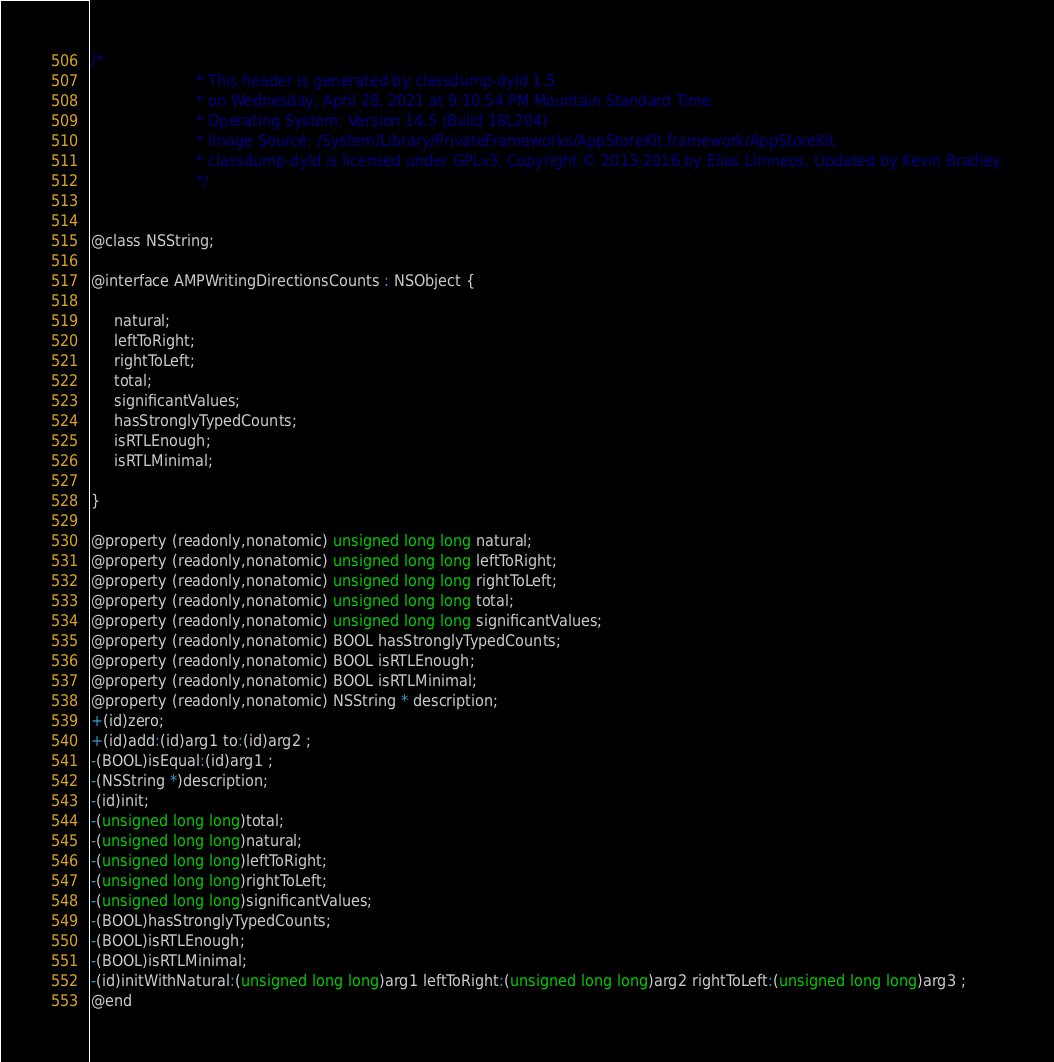<code> <loc_0><loc_0><loc_500><loc_500><_C_>/*
                       * This header is generated by classdump-dyld 1.5
                       * on Wednesday, April 28, 2021 at 9:10:54 PM Mountain Standard Time
                       * Operating System: Version 14.5 (Build 18L204)
                       * Image Source: /System/Library/PrivateFrameworks/AppStoreKit.framework/AppStoreKit
                       * classdump-dyld is licensed under GPLv3, Copyright © 2013-2016 by Elias Limneos. Updated by Kevin Bradley.
                       */


@class NSString;

@interface AMPWritingDirectionsCounts : NSObject {

	 natural;
	 leftToRight;
	 rightToLeft;
	 total;
	 significantValues;
	 hasStronglyTypedCounts;
	 isRTLEnough;
	 isRTLMinimal;

}

@property (readonly,nonatomic) unsigned long long natural; 
@property (readonly,nonatomic) unsigned long long leftToRight; 
@property (readonly,nonatomic) unsigned long long rightToLeft; 
@property (readonly,nonatomic) unsigned long long total; 
@property (readonly,nonatomic) unsigned long long significantValues; 
@property (readonly,nonatomic) BOOL hasStronglyTypedCounts; 
@property (readonly,nonatomic) BOOL isRTLEnough; 
@property (readonly,nonatomic) BOOL isRTLMinimal; 
@property (readonly,nonatomic) NSString * description; 
+(id)zero;
+(id)add:(id)arg1 to:(id)arg2 ;
-(BOOL)isEqual:(id)arg1 ;
-(NSString *)description;
-(id)init;
-(unsigned long long)total;
-(unsigned long long)natural;
-(unsigned long long)leftToRight;
-(unsigned long long)rightToLeft;
-(unsigned long long)significantValues;
-(BOOL)hasStronglyTypedCounts;
-(BOOL)isRTLEnough;
-(BOOL)isRTLMinimal;
-(id)initWithNatural:(unsigned long long)arg1 leftToRight:(unsigned long long)arg2 rightToLeft:(unsigned long long)arg3 ;
@end

</code> 